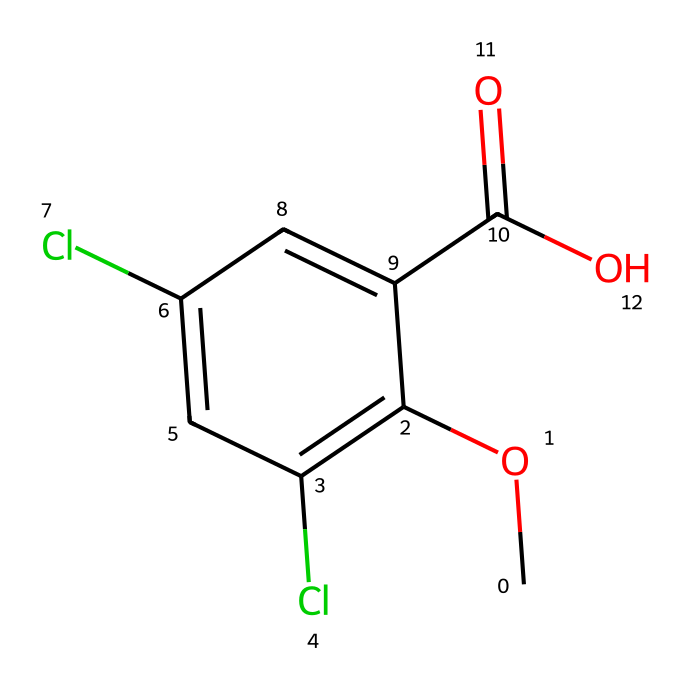What is the molecular formula of dicamba? To determine the molecular formula from the SMILES representation, we identify the atoms. The given SMILES shows carbon (C), hydrogen (H), oxygen (O), and chlorine (Cl) atoms. Count the atoms: there are 10 carbons, 9 hydrogens, 2 oxygens, and 2 chlorines. Therefore, the molecular formula is C10H9Cl2O2.
Answer: C10H9Cl2O2 How many chlorine atoms are in dicamba? By examining the SMILES representation, we can see the presence of two "Cl" labels, indicating the chemical contains two chlorine atoms.
Answer: 2 What type of herbicide is dicamba classified as? Dicamba, as indicated by its structure which features a benzoic acid core, is classified as a benzoic acid herbicide.
Answer: benzoic acid How many rings are present in the structure of dicamba? In the SMILES representation, the ring is indicated by the 'c' notations. In this case, there is one aromatic ring which contains the carbon atoms. Hence, the total number of rings present is 1.
Answer: 1 What functional group is present in dicamba? The structure includes a -COOH group, which identifies as a carboxylic acid functional group. This can be seen in the chemical structure as it has a carbon double-bonded to an oxygen and single-bonded to a hydroxyl (OH), indicative of acidity.
Answer: carboxylic acid What effect do chlorine substituents have on dicamba? The presence of chlorine atoms in the chemical structure often increases the herbicide's stability and can also enhance its herbicidal properties, suggesting that these groups influence the herbicidal activity.
Answer: enhance stability 